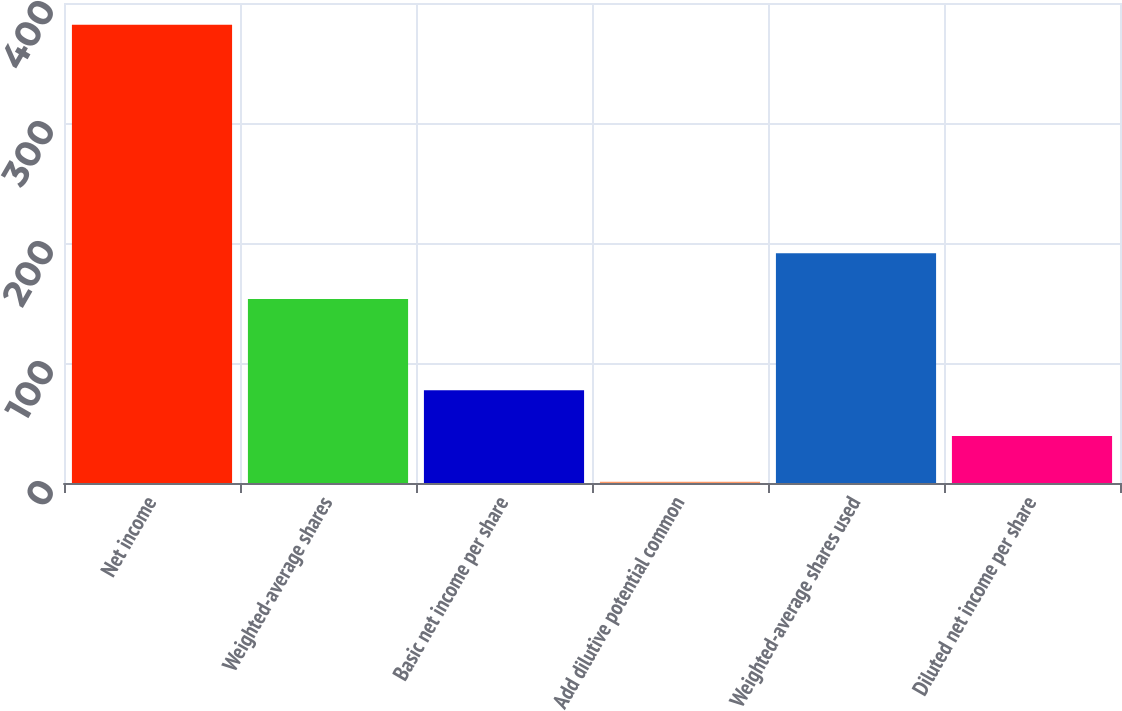Convert chart. <chart><loc_0><loc_0><loc_500><loc_500><bar_chart><fcel>Net income<fcel>Weighted-average shares<fcel>Basic net income per share<fcel>Add dilutive potential common<fcel>Weighted-average shares used<fcel>Diluted net income per share<nl><fcel>381.8<fcel>153.38<fcel>77.24<fcel>1.1<fcel>191.45<fcel>39.17<nl></chart> 